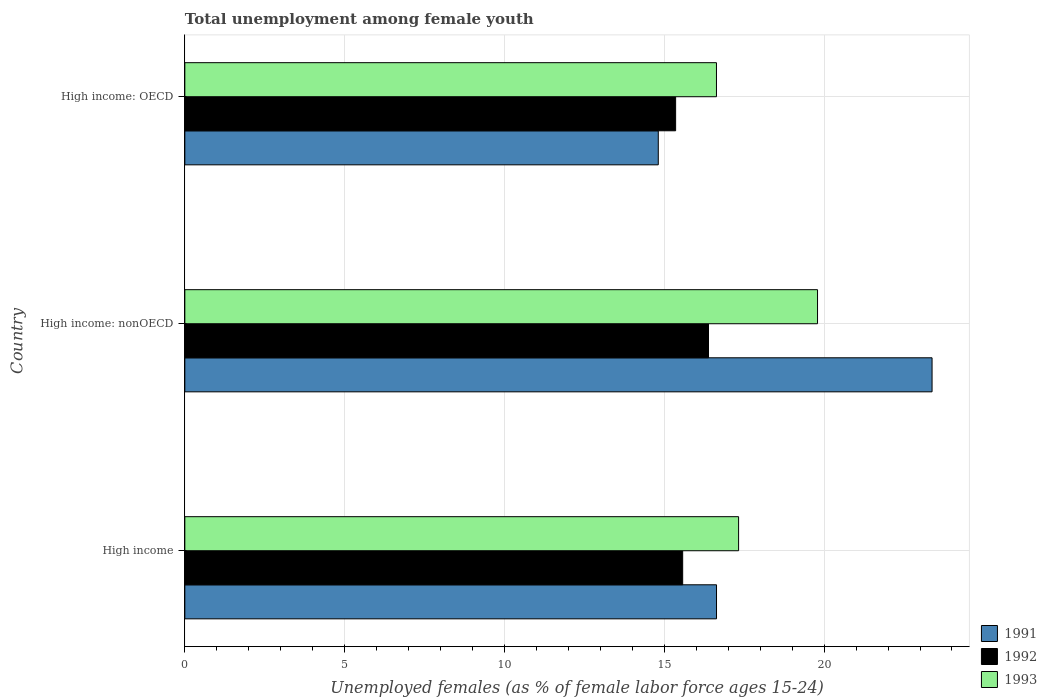How many different coloured bars are there?
Your answer should be compact. 3. How many groups of bars are there?
Make the answer very short. 3. Are the number of bars per tick equal to the number of legend labels?
Offer a very short reply. Yes. How many bars are there on the 1st tick from the bottom?
Ensure brevity in your answer.  3. What is the label of the 2nd group of bars from the top?
Make the answer very short. High income: nonOECD. In how many cases, is the number of bars for a given country not equal to the number of legend labels?
Your response must be concise. 0. What is the percentage of unemployed females in in 1993 in High income: OECD?
Ensure brevity in your answer.  16.63. Across all countries, what is the maximum percentage of unemployed females in in 1993?
Offer a terse response. 19.79. Across all countries, what is the minimum percentage of unemployed females in in 1992?
Give a very brief answer. 15.35. In which country was the percentage of unemployed females in in 1991 maximum?
Give a very brief answer. High income: nonOECD. In which country was the percentage of unemployed females in in 1991 minimum?
Ensure brevity in your answer.  High income: OECD. What is the total percentage of unemployed females in in 1991 in the graph?
Your answer should be very brief. 54.82. What is the difference between the percentage of unemployed females in in 1993 in High income and that in High income: OECD?
Your response must be concise. 0.69. What is the difference between the percentage of unemployed females in in 1993 in High income and the percentage of unemployed females in in 1991 in High income: nonOECD?
Your answer should be very brief. -6.05. What is the average percentage of unemployed females in in 1993 per country?
Offer a terse response. 17.92. What is the difference between the percentage of unemployed females in in 1991 and percentage of unemployed females in in 1992 in High income?
Keep it short and to the point. 1.06. In how many countries, is the percentage of unemployed females in in 1991 greater than 2 %?
Your answer should be very brief. 3. What is the ratio of the percentage of unemployed females in in 1991 in High income to that in High income: OECD?
Ensure brevity in your answer.  1.12. Is the difference between the percentage of unemployed females in in 1991 in High income and High income: OECD greater than the difference between the percentage of unemployed females in in 1992 in High income and High income: OECD?
Your answer should be very brief. Yes. What is the difference between the highest and the second highest percentage of unemployed females in in 1992?
Keep it short and to the point. 0.81. What is the difference between the highest and the lowest percentage of unemployed females in in 1992?
Offer a very short reply. 1.03. In how many countries, is the percentage of unemployed females in in 1991 greater than the average percentage of unemployed females in in 1991 taken over all countries?
Give a very brief answer. 1. Is the sum of the percentage of unemployed females in in 1992 in High income: OECD and High income: nonOECD greater than the maximum percentage of unemployed females in in 1993 across all countries?
Your answer should be very brief. Yes. What does the 2nd bar from the top in High income: OECD represents?
Make the answer very short. 1992. Are the values on the major ticks of X-axis written in scientific E-notation?
Your response must be concise. No. What is the title of the graph?
Keep it short and to the point. Total unemployment among female youth. What is the label or title of the X-axis?
Keep it short and to the point. Unemployed females (as % of female labor force ages 15-24). What is the Unemployed females (as % of female labor force ages 15-24) in 1991 in High income?
Ensure brevity in your answer.  16.63. What is the Unemployed females (as % of female labor force ages 15-24) of 1992 in High income?
Your answer should be very brief. 15.57. What is the Unemployed females (as % of female labor force ages 15-24) in 1993 in High income?
Provide a short and direct response. 17.32. What is the Unemployed females (as % of female labor force ages 15-24) of 1991 in High income: nonOECD?
Offer a very short reply. 23.38. What is the Unemployed females (as % of female labor force ages 15-24) of 1992 in High income: nonOECD?
Ensure brevity in your answer.  16.38. What is the Unemployed females (as % of female labor force ages 15-24) of 1993 in High income: nonOECD?
Offer a very short reply. 19.79. What is the Unemployed females (as % of female labor force ages 15-24) of 1991 in High income: OECD?
Provide a succinct answer. 14.81. What is the Unemployed females (as % of female labor force ages 15-24) of 1992 in High income: OECD?
Keep it short and to the point. 15.35. What is the Unemployed females (as % of female labor force ages 15-24) of 1993 in High income: OECD?
Ensure brevity in your answer.  16.63. Across all countries, what is the maximum Unemployed females (as % of female labor force ages 15-24) of 1991?
Give a very brief answer. 23.38. Across all countries, what is the maximum Unemployed females (as % of female labor force ages 15-24) in 1992?
Provide a short and direct response. 16.38. Across all countries, what is the maximum Unemployed females (as % of female labor force ages 15-24) of 1993?
Give a very brief answer. 19.79. Across all countries, what is the minimum Unemployed females (as % of female labor force ages 15-24) in 1991?
Keep it short and to the point. 14.81. Across all countries, what is the minimum Unemployed females (as % of female labor force ages 15-24) of 1992?
Your response must be concise. 15.35. Across all countries, what is the minimum Unemployed females (as % of female labor force ages 15-24) in 1993?
Your answer should be compact. 16.63. What is the total Unemployed females (as % of female labor force ages 15-24) in 1991 in the graph?
Keep it short and to the point. 54.82. What is the total Unemployed females (as % of female labor force ages 15-24) of 1992 in the graph?
Offer a very short reply. 47.31. What is the total Unemployed females (as % of female labor force ages 15-24) of 1993 in the graph?
Ensure brevity in your answer.  53.75. What is the difference between the Unemployed females (as % of female labor force ages 15-24) of 1991 in High income and that in High income: nonOECD?
Provide a short and direct response. -6.74. What is the difference between the Unemployed females (as % of female labor force ages 15-24) in 1992 in High income and that in High income: nonOECD?
Give a very brief answer. -0.81. What is the difference between the Unemployed females (as % of female labor force ages 15-24) of 1993 in High income and that in High income: nonOECD?
Your response must be concise. -2.47. What is the difference between the Unemployed females (as % of female labor force ages 15-24) of 1991 in High income and that in High income: OECD?
Keep it short and to the point. 1.82. What is the difference between the Unemployed females (as % of female labor force ages 15-24) in 1992 in High income and that in High income: OECD?
Keep it short and to the point. 0.22. What is the difference between the Unemployed females (as % of female labor force ages 15-24) in 1993 in High income and that in High income: OECD?
Offer a terse response. 0.69. What is the difference between the Unemployed females (as % of female labor force ages 15-24) in 1991 in High income: nonOECD and that in High income: OECD?
Offer a terse response. 8.57. What is the difference between the Unemployed females (as % of female labor force ages 15-24) in 1992 in High income: nonOECD and that in High income: OECD?
Provide a succinct answer. 1.03. What is the difference between the Unemployed females (as % of female labor force ages 15-24) in 1993 in High income: nonOECD and that in High income: OECD?
Your response must be concise. 3.16. What is the difference between the Unemployed females (as % of female labor force ages 15-24) of 1991 in High income and the Unemployed females (as % of female labor force ages 15-24) of 1992 in High income: nonOECD?
Ensure brevity in your answer.  0.25. What is the difference between the Unemployed females (as % of female labor force ages 15-24) of 1991 in High income and the Unemployed females (as % of female labor force ages 15-24) of 1993 in High income: nonOECD?
Your response must be concise. -3.16. What is the difference between the Unemployed females (as % of female labor force ages 15-24) in 1992 in High income and the Unemployed females (as % of female labor force ages 15-24) in 1993 in High income: nonOECD?
Offer a very short reply. -4.22. What is the difference between the Unemployed females (as % of female labor force ages 15-24) of 1991 in High income and the Unemployed females (as % of female labor force ages 15-24) of 1992 in High income: OECD?
Your response must be concise. 1.28. What is the difference between the Unemployed females (as % of female labor force ages 15-24) in 1991 in High income and the Unemployed females (as % of female labor force ages 15-24) in 1993 in High income: OECD?
Offer a very short reply. 0. What is the difference between the Unemployed females (as % of female labor force ages 15-24) in 1992 in High income and the Unemployed females (as % of female labor force ages 15-24) in 1993 in High income: OECD?
Offer a terse response. -1.06. What is the difference between the Unemployed females (as % of female labor force ages 15-24) in 1991 in High income: nonOECD and the Unemployed females (as % of female labor force ages 15-24) in 1992 in High income: OECD?
Give a very brief answer. 8.02. What is the difference between the Unemployed females (as % of female labor force ages 15-24) in 1991 in High income: nonOECD and the Unemployed females (as % of female labor force ages 15-24) in 1993 in High income: OECD?
Give a very brief answer. 6.75. What is the difference between the Unemployed females (as % of female labor force ages 15-24) of 1992 in High income: nonOECD and the Unemployed females (as % of female labor force ages 15-24) of 1993 in High income: OECD?
Ensure brevity in your answer.  -0.25. What is the average Unemployed females (as % of female labor force ages 15-24) of 1991 per country?
Your answer should be compact. 18.27. What is the average Unemployed females (as % of female labor force ages 15-24) of 1992 per country?
Offer a very short reply. 15.77. What is the average Unemployed females (as % of female labor force ages 15-24) of 1993 per country?
Offer a terse response. 17.92. What is the difference between the Unemployed females (as % of female labor force ages 15-24) in 1991 and Unemployed females (as % of female labor force ages 15-24) in 1992 in High income?
Your answer should be very brief. 1.06. What is the difference between the Unemployed females (as % of female labor force ages 15-24) of 1991 and Unemployed females (as % of female labor force ages 15-24) of 1993 in High income?
Provide a succinct answer. -0.69. What is the difference between the Unemployed females (as % of female labor force ages 15-24) of 1992 and Unemployed females (as % of female labor force ages 15-24) of 1993 in High income?
Your answer should be very brief. -1.75. What is the difference between the Unemployed females (as % of female labor force ages 15-24) of 1991 and Unemployed females (as % of female labor force ages 15-24) of 1992 in High income: nonOECD?
Your response must be concise. 6.99. What is the difference between the Unemployed females (as % of female labor force ages 15-24) in 1991 and Unemployed females (as % of female labor force ages 15-24) in 1993 in High income: nonOECD?
Provide a short and direct response. 3.58. What is the difference between the Unemployed females (as % of female labor force ages 15-24) in 1992 and Unemployed females (as % of female labor force ages 15-24) in 1993 in High income: nonOECD?
Offer a terse response. -3.41. What is the difference between the Unemployed females (as % of female labor force ages 15-24) in 1991 and Unemployed females (as % of female labor force ages 15-24) in 1992 in High income: OECD?
Ensure brevity in your answer.  -0.54. What is the difference between the Unemployed females (as % of female labor force ages 15-24) of 1991 and Unemployed females (as % of female labor force ages 15-24) of 1993 in High income: OECD?
Offer a terse response. -1.82. What is the difference between the Unemployed females (as % of female labor force ages 15-24) in 1992 and Unemployed females (as % of female labor force ages 15-24) in 1993 in High income: OECD?
Offer a terse response. -1.28. What is the ratio of the Unemployed females (as % of female labor force ages 15-24) of 1991 in High income to that in High income: nonOECD?
Ensure brevity in your answer.  0.71. What is the ratio of the Unemployed females (as % of female labor force ages 15-24) of 1992 in High income to that in High income: nonOECD?
Provide a short and direct response. 0.95. What is the ratio of the Unemployed females (as % of female labor force ages 15-24) in 1993 in High income to that in High income: nonOECD?
Provide a short and direct response. 0.88. What is the ratio of the Unemployed females (as % of female labor force ages 15-24) in 1991 in High income to that in High income: OECD?
Your response must be concise. 1.12. What is the ratio of the Unemployed females (as % of female labor force ages 15-24) of 1992 in High income to that in High income: OECD?
Keep it short and to the point. 1.01. What is the ratio of the Unemployed females (as % of female labor force ages 15-24) in 1993 in High income to that in High income: OECD?
Offer a terse response. 1.04. What is the ratio of the Unemployed females (as % of female labor force ages 15-24) in 1991 in High income: nonOECD to that in High income: OECD?
Provide a short and direct response. 1.58. What is the ratio of the Unemployed females (as % of female labor force ages 15-24) in 1992 in High income: nonOECD to that in High income: OECD?
Provide a succinct answer. 1.07. What is the ratio of the Unemployed females (as % of female labor force ages 15-24) in 1993 in High income: nonOECD to that in High income: OECD?
Give a very brief answer. 1.19. What is the difference between the highest and the second highest Unemployed females (as % of female labor force ages 15-24) in 1991?
Give a very brief answer. 6.74. What is the difference between the highest and the second highest Unemployed females (as % of female labor force ages 15-24) in 1992?
Your answer should be compact. 0.81. What is the difference between the highest and the second highest Unemployed females (as % of female labor force ages 15-24) in 1993?
Your answer should be very brief. 2.47. What is the difference between the highest and the lowest Unemployed females (as % of female labor force ages 15-24) in 1991?
Keep it short and to the point. 8.57. What is the difference between the highest and the lowest Unemployed females (as % of female labor force ages 15-24) in 1992?
Ensure brevity in your answer.  1.03. What is the difference between the highest and the lowest Unemployed females (as % of female labor force ages 15-24) of 1993?
Keep it short and to the point. 3.16. 